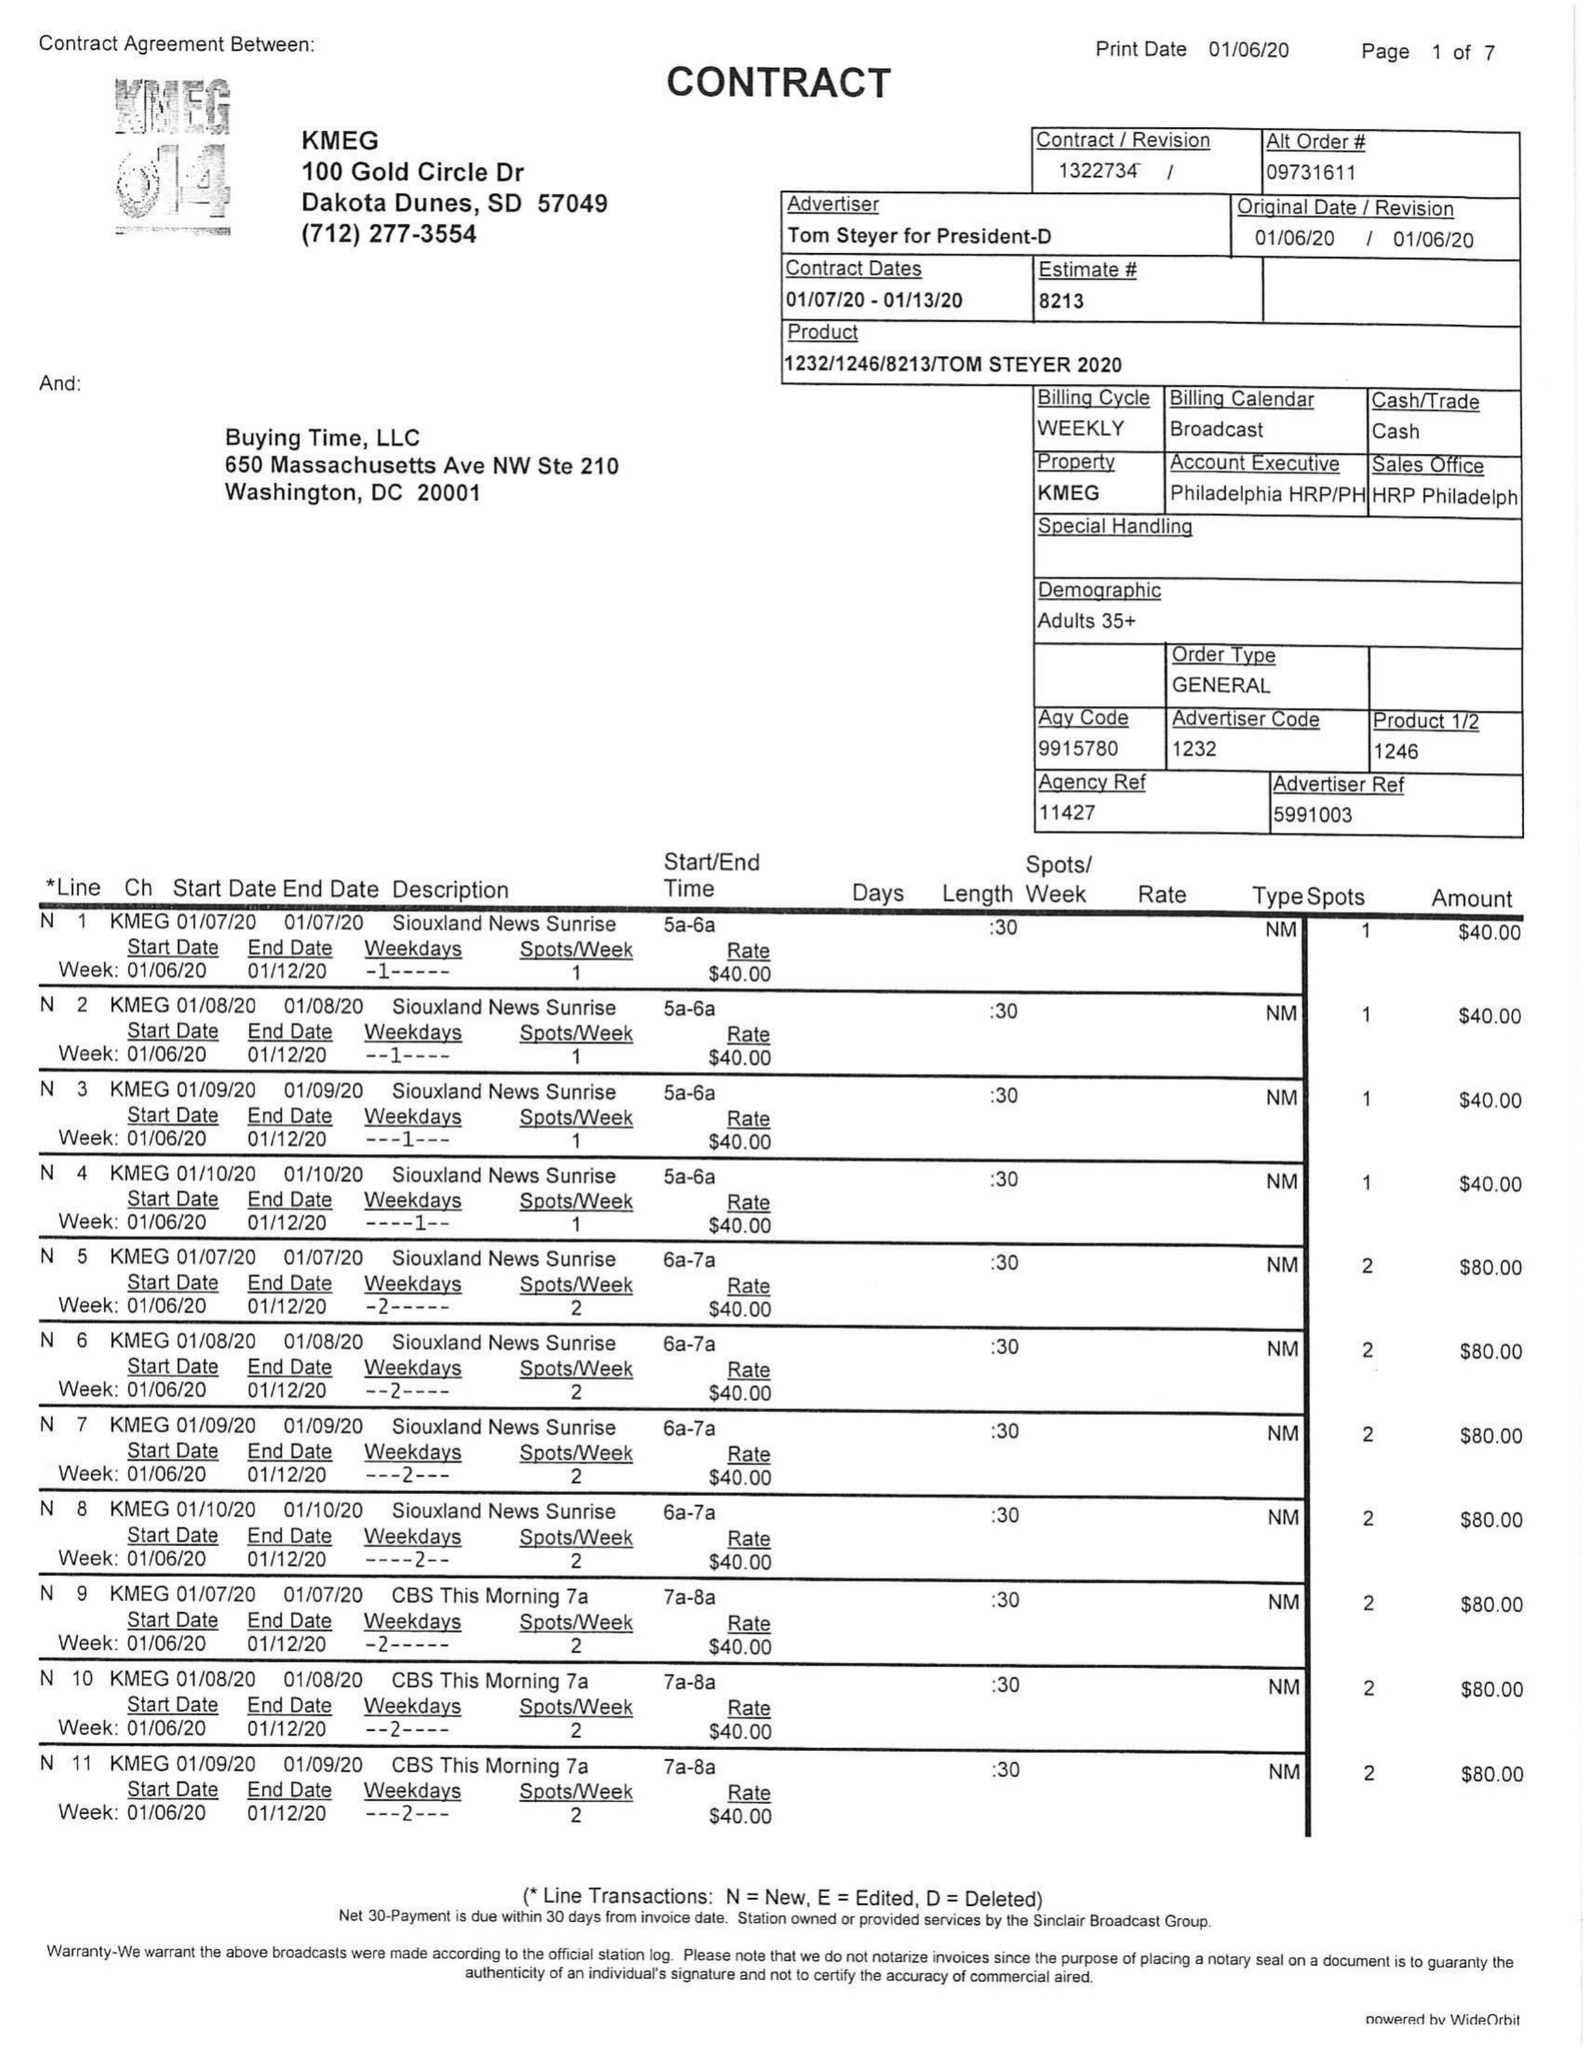What is the value for the gross_amount?
Answer the question using a single word or phrase. 21125.00 